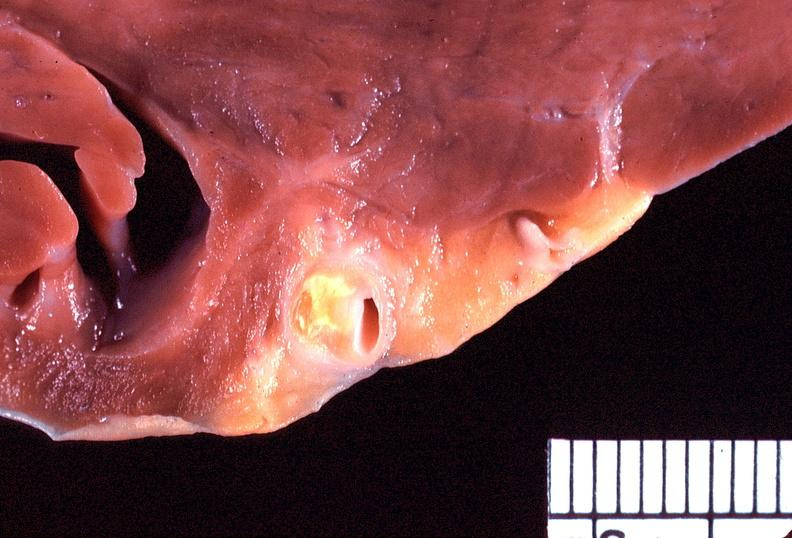does this image show heart, coronary artery, atherosclerosis?
Answer the question using a single word or phrase. Yes 